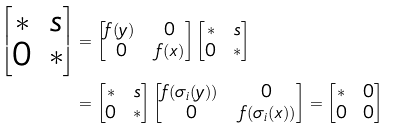<formula> <loc_0><loc_0><loc_500><loc_500>\begin{bmatrix} * & s \\ 0 & * \end{bmatrix} & = \begin{bmatrix} f ( y ) \, & 0 \\ 0 & \, f ( x ) \end{bmatrix} \begin{bmatrix} * & s \\ 0 & * \end{bmatrix} \\ & = \begin{bmatrix} * & s \\ 0 & * \end{bmatrix} \begin{bmatrix} f ( \sigma _ { i } ( y ) ) \, & 0 \\ 0 & \, f ( \sigma _ { i } ( x ) ) \end{bmatrix} = \begin{bmatrix} * & 0 \\ 0 & 0 \end{bmatrix}</formula> 